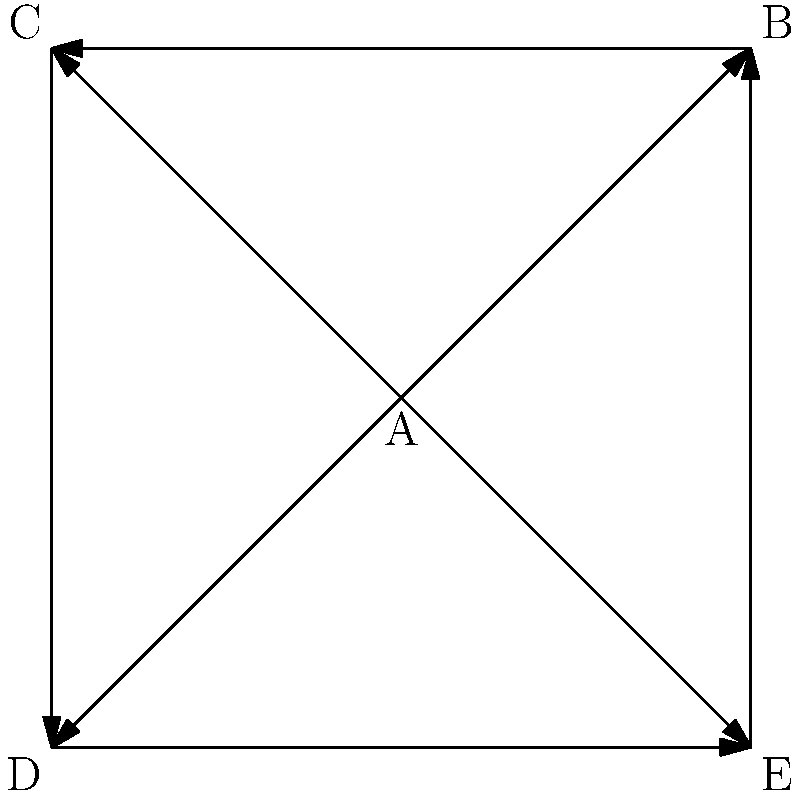In the context of a historical social network analysis focusing on non-monarchical figures, consider the graph above where each node represents a significant historical figure and each directed edge represents a documented influence. Which figure has the highest out-degree centrality, potentially indicating the most direct influence on others? To determine the figure with the highest out-degree centrality, we need to count the number of outgoing edges for each node in the graph. This measure indicates how many other figures a particular individual directly influenced.

Step 1: Count outgoing edges for each node:
A: 4 outgoing edges (to B, C, D, and E)
B: 1 outgoing edge (to C)
C: 1 outgoing edge (to D)
D: 1 outgoing edge (to E)
E: 1 outgoing edge (to B)

Step 2: Compare the counts:
A has the highest number of outgoing edges with 4, while all other nodes have only 1 outgoing edge each.

Step 3: Interpret the result:
In the context of non-monarchical historical figures, the node A represents the individual who had direct influence over the most other figures in this network. This could represent a key intellectual, political leader, or social reformer who shaped the ideas or actions of many contemporaries.
Answer: A 